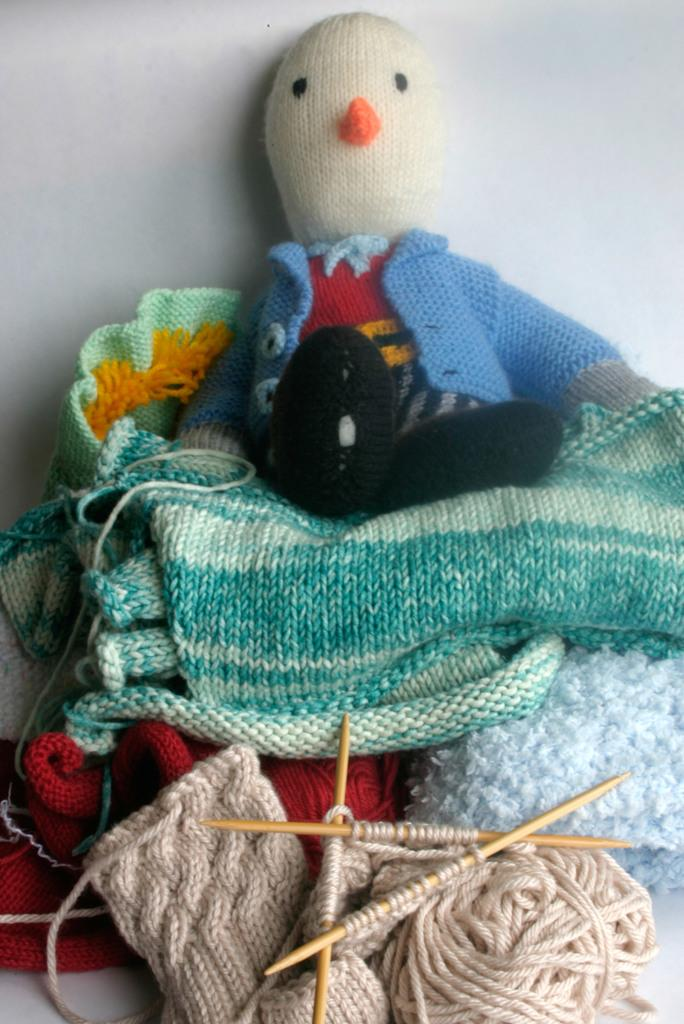What objects can be seen in the image that are used for crafting or creating? In the image, there are sticks and woolen threads that can be used for crafting or creating. What type of item is visible in the image that might be used for playing or as a decoration? There is a doll in the image that can be used for playing or as a decoration. What type of clothing can be seen in the image? There are clothes in the image. What can be seen in the background of the image? There is a wall visible in the background of the image. What observation can be made about the birth of the doll in the image? There is no information about the birth of the doll in the image, as it is a manufactured item. Is there a fire visible in the image? No, there is no fire visible in the image. 